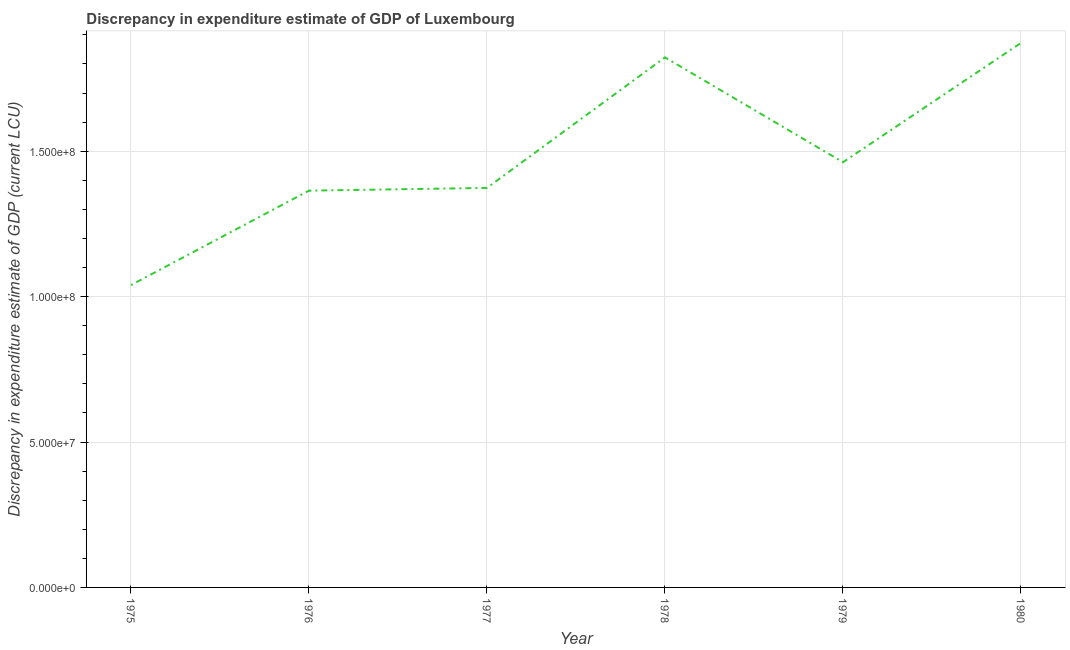What is the discrepancy in expenditure estimate of gdp in 1978?
Offer a very short reply. 1.82e+08. Across all years, what is the maximum discrepancy in expenditure estimate of gdp?
Provide a short and direct response. 1.87e+08. Across all years, what is the minimum discrepancy in expenditure estimate of gdp?
Make the answer very short. 1.04e+08. In which year was the discrepancy in expenditure estimate of gdp minimum?
Make the answer very short. 1975. What is the sum of the discrepancy in expenditure estimate of gdp?
Provide a succinct answer. 8.93e+08. What is the difference between the discrepancy in expenditure estimate of gdp in 1975 and 1979?
Provide a short and direct response. -4.23e+07. What is the average discrepancy in expenditure estimate of gdp per year?
Your response must be concise. 1.49e+08. What is the median discrepancy in expenditure estimate of gdp?
Keep it short and to the point. 1.42e+08. What is the ratio of the discrepancy in expenditure estimate of gdp in 1975 to that in 1980?
Your response must be concise. 0.56. What is the difference between the highest and the second highest discrepancy in expenditure estimate of gdp?
Your answer should be compact. 4.97e+06. Is the sum of the discrepancy in expenditure estimate of gdp in 1978 and 1979 greater than the maximum discrepancy in expenditure estimate of gdp across all years?
Provide a short and direct response. Yes. What is the difference between the highest and the lowest discrepancy in expenditure estimate of gdp?
Your answer should be very brief. 8.33e+07. In how many years, is the discrepancy in expenditure estimate of gdp greater than the average discrepancy in expenditure estimate of gdp taken over all years?
Give a very brief answer. 2. Does the discrepancy in expenditure estimate of gdp monotonically increase over the years?
Offer a terse response. No. Does the graph contain any zero values?
Make the answer very short. No. Does the graph contain grids?
Ensure brevity in your answer.  Yes. What is the title of the graph?
Provide a succinct answer. Discrepancy in expenditure estimate of GDP of Luxembourg. What is the label or title of the X-axis?
Make the answer very short. Year. What is the label or title of the Y-axis?
Offer a very short reply. Discrepancy in expenditure estimate of GDP (current LCU). What is the Discrepancy in expenditure estimate of GDP (current LCU) of 1975?
Give a very brief answer. 1.04e+08. What is the Discrepancy in expenditure estimate of GDP (current LCU) of 1976?
Give a very brief answer. 1.36e+08. What is the Discrepancy in expenditure estimate of GDP (current LCU) of 1977?
Give a very brief answer. 1.37e+08. What is the Discrepancy in expenditure estimate of GDP (current LCU) in 1978?
Your answer should be compact. 1.82e+08. What is the Discrepancy in expenditure estimate of GDP (current LCU) in 1979?
Keep it short and to the point. 1.46e+08. What is the Discrepancy in expenditure estimate of GDP (current LCU) of 1980?
Make the answer very short. 1.87e+08. What is the difference between the Discrepancy in expenditure estimate of GDP (current LCU) in 1975 and 1976?
Give a very brief answer. -3.25e+07. What is the difference between the Discrepancy in expenditure estimate of GDP (current LCU) in 1975 and 1977?
Offer a terse response. -3.34e+07. What is the difference between the Discrepancy in expenditure estimate of GDP (current LCU) in 1975 and 1978?
Give a very brief answer. -7.83e+07. What is the difference between the Discrepancy in expenditure estimate of GDP (current LCU) in 1975 and 1979?
Provide a short and direct response. -4.23e+07. What is the difference between the Discrepancy in expenditure estimate of GDP (current LCU) in 1975 and 1980?
Your response must be concise. -8.33e+07. What is the difference between the Discrepancy in expenditure estimate of GDP (current LCU) in 1976 and 1977?
Offer a very short reply. -9.37e+05. What is the difference between the Discrepancy in expenditure estimate of GDP (current LCU) in 1976 and 1978?
Give a very brief answer. -4.58e+07. What is the difference between the Discrepancy in expenditure estimate of GDP (current LCU) in 1976 and 1979?
Make the answer very short. -9.78e+06. What is the difference between the Discrepancy in expenditure estimate of GDP (current LCU) in 1976 and 1980?
Offer a terse response. -5.08e+07. What is the difference between the Discrepancy in expenditure estimate of GDP (current LCU) in 1977 and 1978?
Keep it short and to the point. -4.49e+07. What is the difference between the Discrepancy in expenditure estimate of GDP (current LCU) in 1977 and 1979?
Offer a very short reply. -8.84e+06. What is the difference between the Discrepancy in expenditure estimate of GDP (current LCU) in 1977 and 1980?
Your response must be concise. -4.98e+07. What is the difference between the Discrepancy in expenditure estimate of GDP (current LCU) in 1978 and 1979?
Give a very brief answer. 3.60e+07. What is the difference between the Discrepancy in expenditure estimate of GDP (current LCU) in 1978 and 1980?
Provide a short and direct response. -4.97e+06. What is the difference between the Discrepancy in expenditure estimate of GDP (current LCU) in 1979 and 1980?
Your answer should be very brief. -4.10e+07. What is the ratio of the Discrepancy in expenditure estimate of GDP (current LCU) in 1975 to that in 1976?
Keep it short and to the point. 0.76. What is the ratio of the Discrepancy in expenditure estimate of GDP (current LCU) in 1975 to that in 1977?
Offer a very short reply. 0.76. What is the ratio of the Discrepancy in expenditure estimate of GDP (current LCU) in 1975 to that in 1978?
Keep it short and to the point. 0.57. What is the ratio of the Discrepancy in expenditure estimate of GDP (current LCU) in 1975 to that in 1979?
Offer a very short reply. 0.71. What is the ratio of the Discrepancy in expenditure estimate of GDP (current LCU) in 1975 to that in 1980?
Your answer should be very brief. 0.56. What is the ratio of the Discrepancy in expenditure estimate of GDP (current LCU) in 1976 to that in 1978?
Give a very brief answer. 0.75. What is the ratio of the Discrepancy in expenditure estimate of GDP (current LCU) in 1976 to that in 1979?
Provide a short and direct response. 0.93. What is the ratio of the Discrepancy in expenditure estimate of GDP (current LCU) in 1976 to that in 1980?
Offer a very short reply. 0.73. What is the ratio of the Discrepancy in expenditure estimate of GDP (current LCU) in 1977 to that in 1978?
Offer a very short reply. 0.75. What is the ratio of the Discrepancy in expenditure estimate of GDP (current LCU) in 1977 to that in 1979?
Give a very brief answer. 0.94. What is the ratio of the Discrepancy in expenditure estimate of GDP (current LCU) in 1977 to that in 1980?
Ensure brevity in your answer.  0.73. What is the ratio of the Discrepancy in expenditure estimate of GDP (current LCU) in 1978 to that in 1979?
Keep it short and to the point. 1.25. What is the ratio of the Discrepancy in expenditure estimate of GDP (current LCU) in 1979 to that in 1980?
Your response must be concise. 0.78. 